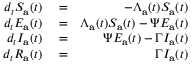Convert formula to latex. <formula><loc_0><loc_0><loc_500><loc_500>\begin{array} { r l r } { d _ { t } S _ { a } ( t ) } & = } & { - \Lambda _ { a } ( t ) S _ { a } ( t ) } \\ { d _ { t } E _ { a } ( t ) } & = } & { \Lambda _ { a } ( t ) S _ { a } ( t ) - \Psi E _ { a } ( t ) } \\ { d _ { t } I _ { a } ( t ) } & = } & { \Psi E _ { a } ( t ) - \Gamma I _ { a } ( t ) } \\ { d _ { t } R _ { a } ( t ) } & = } & { \Gamma I _ { a } ( t ) } \end{array}</formula> 